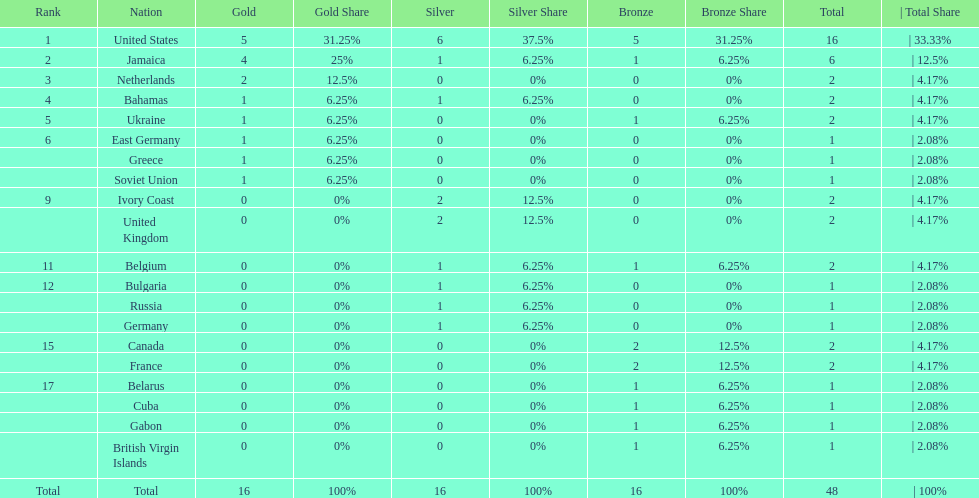What is the average number of gold medals won by the top 5 nations? 2.6. 